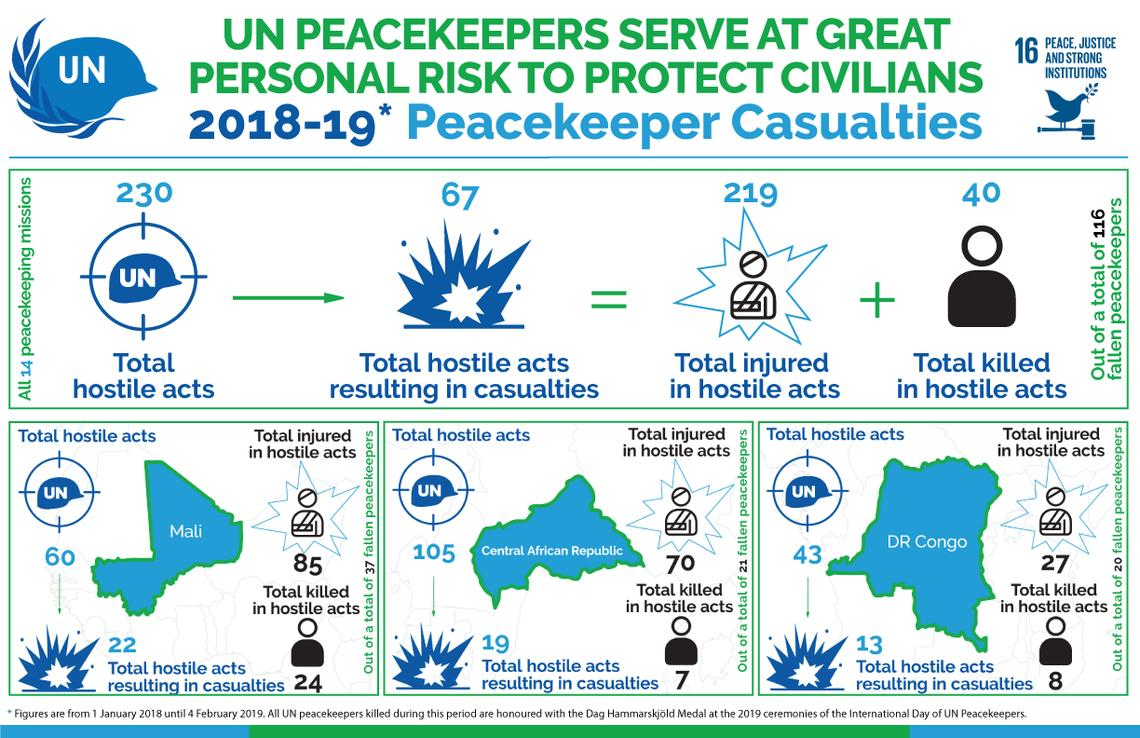Highlight a few significant elements in this photo. The total number of people killed in hostile acts is 40. The number of deaths due to hostile acts was highest in Mali. There were 27 people who were injured as a result of hostile acts in the Congo. Eight people were killed in hostile acts in the Congo. A total of 230 hostile acts were recorded, and of those, 67 resulted in casualties. 